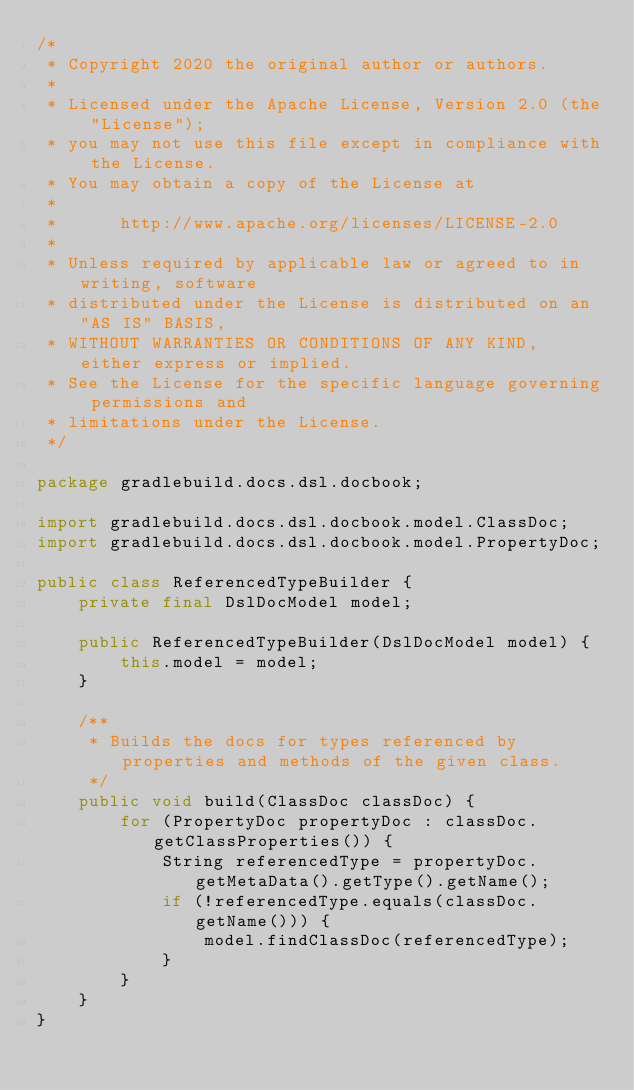<code> <loc_0><loc_0><loc_500><loc_500><_Java_>/*
 * Copyright 2020 the original author or authors.
 *
 * Licensed under the Apache License, Version 2.0 (the "License");
 * you may not use this file except in compliance with the License.
 * You may obtain a copy of the License at
 *
 *      http://www.apache.org/licenses/LICENSE-2.0
 *
 * Unless required by applicable law or agreed to in writing, software
 * distributed under the License is distributed on an "AS IS" BASIS,
 * WITHOUT WARRANTIES OR CONDITIONS OF ANY KIND, either express or implied.
 * See the License for the specific language governing permissions and
 * limitations under the License.
 */

package gradlebuild.docs.dsl.docbook;

import gradlebuild.docs.dsl.docbook.model.ClassDoc;
import gradlebuild.docs.dsl.docbook.model.PropertyDoc;

public class ReferencedTypeBuilder {
    private final DslDocModel model;

    public ReferencedTypeBuilder(DslDocModel model) {
        this.model = model;
    }

    /**
     * Builds the docs for types referenced by properties and methods of the given class.
     */
    public void build(ClassDoc classDoc) {
        for (PropertyDoc propertyDoc : classDoc.getClassProperties()) {
            String referencedType = propertyDoc.getMetaData().getType().getName();
            if (!referencedType.equals(classDoc.getName())) {
                model.findClassDoc(referencedType);
            }
        }
    }
}
</code> 